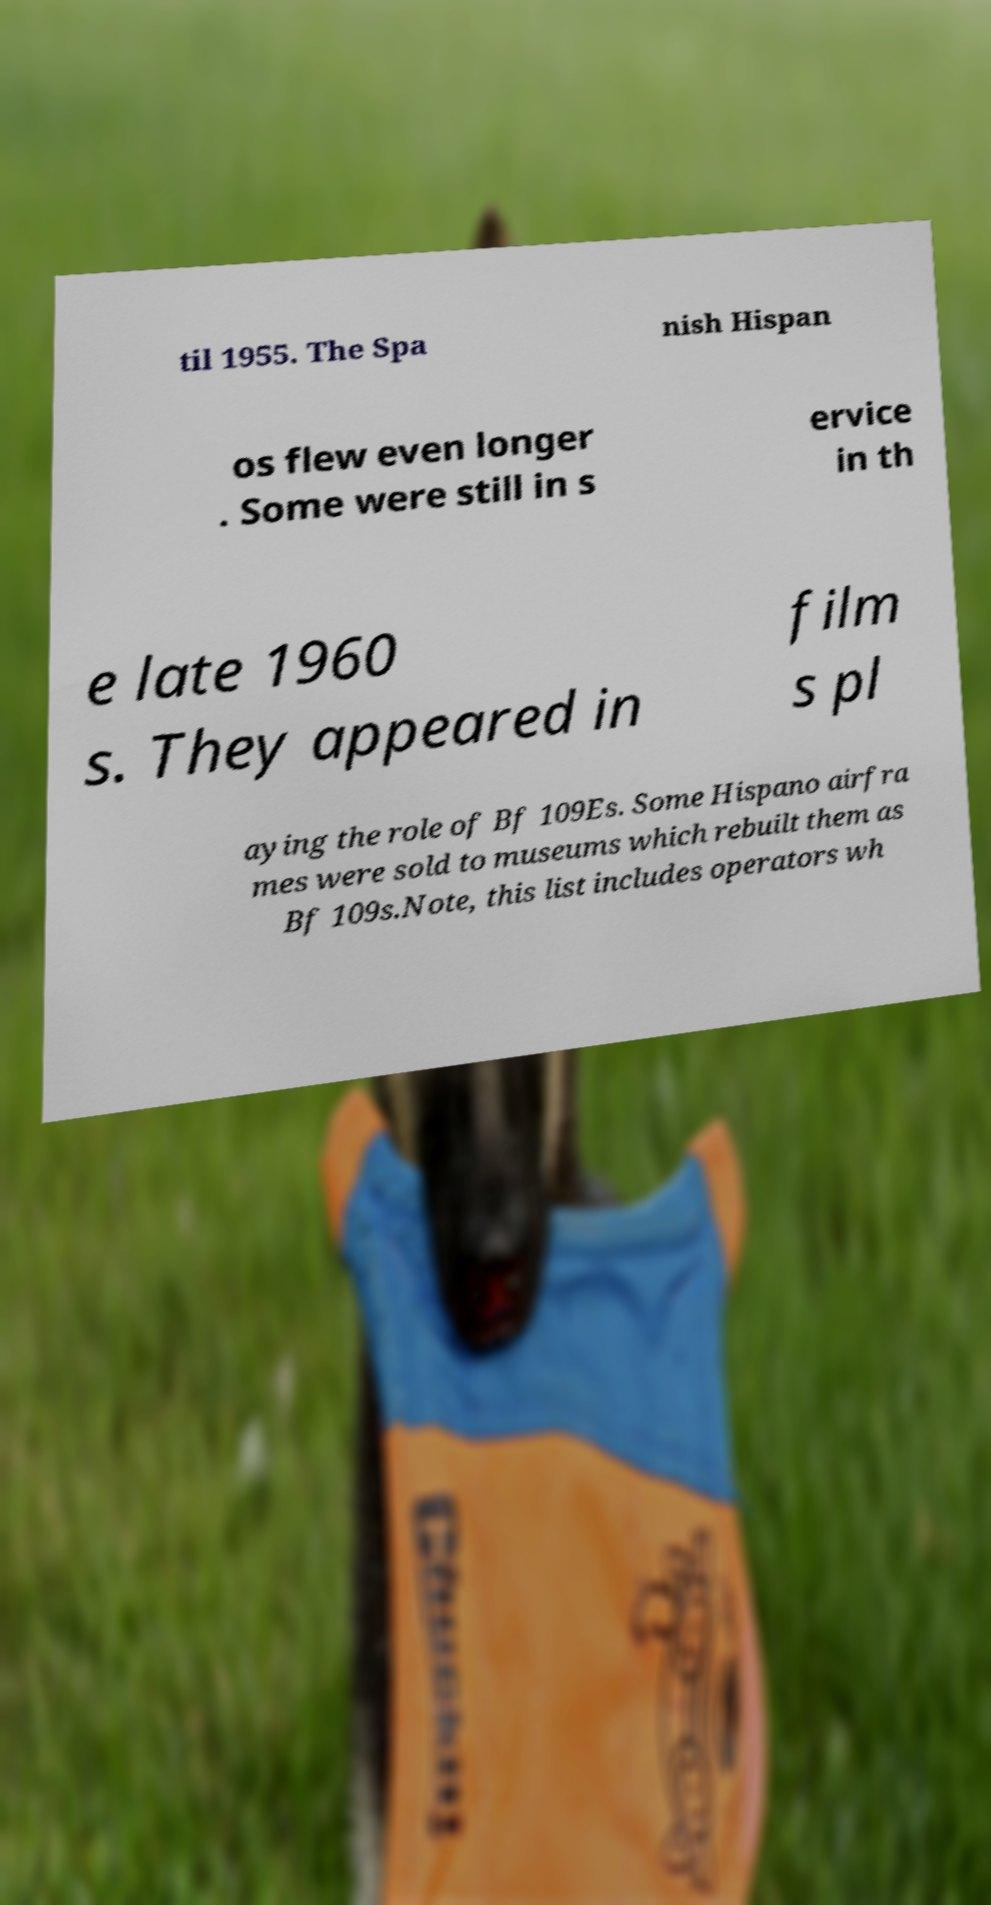Could you assist in decoding the text presented in this image and type it out clearly? til 1955. The Spa nish Hispan os flew even longer . Some were still in s ervice in th e late 1960 s. They appeared in film s pl aying the role of Bf 109Es. Some Hispano airfra mes were sold to museums which rebuilt them as Bf 109s.Note, this list includes operators wh 